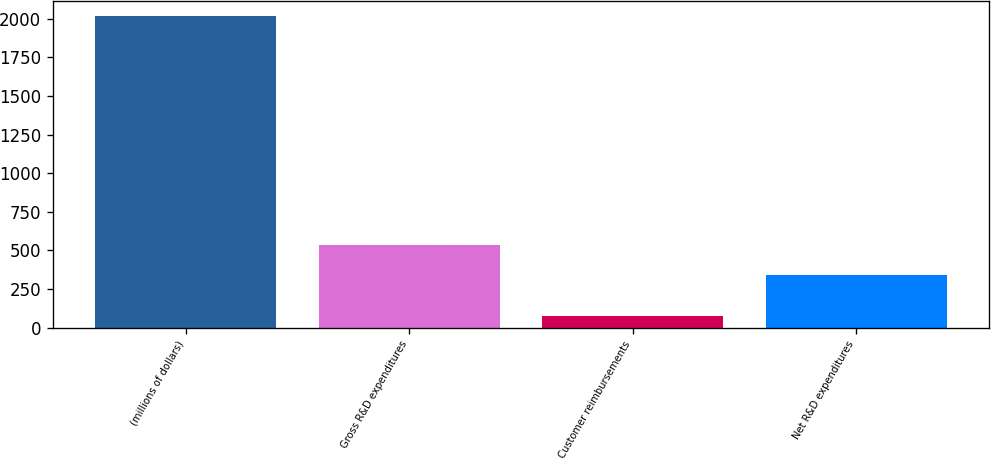Convert chart. <chart><loc_0><loc_0><loc_500><loc_500><bar_chart><fcel>(millions of dollars)<fcel>Gross R&D expenditures<fcel>Customer reimbursements<fcel>Net R&D expenditures<nl><fcel>2016<fcel>537.34<fcel>74.6<fcel>343.2<nl></chart> 